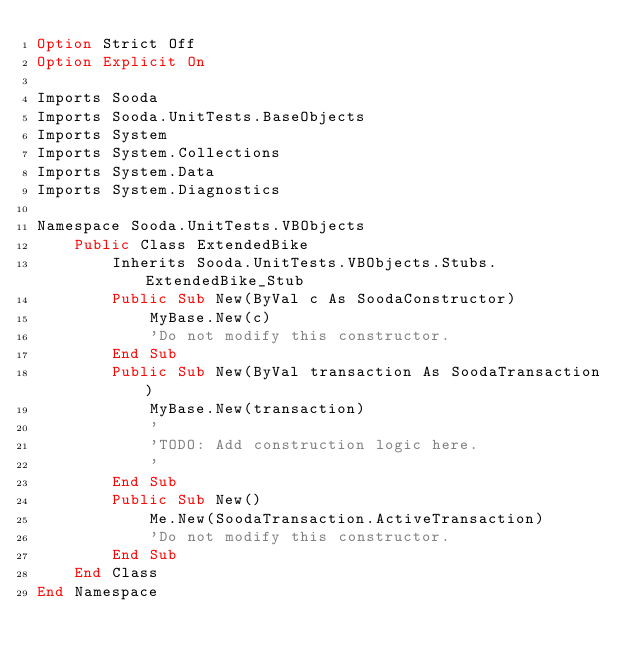<code> <loc_0><loc_0><loc_500><loc_500><_VisualBasic_>Option Strict Off
Option Explicit On

Imports Sooda
Imports Sooda.UnitTests.BaseObjects
Imports System
Imports System.Collections
Imports System.Data
Imports System.Diagnostics

Namespace Sooda.UnitTests.VBObjects
    Public Class ExtendedBike
        Inherits Sooda.UnitTests.VBObjects.Stubs.ExtendedBike_Stub
        Public Sub New(ByVal c As SoodaConstructor)
            MyBase.New(c)
            'Do not modify this constructor.
        End Sub
        Public Sub New(ByVal transaction As SoodaTransaction)
            MyBase.New(transaction)
            '
            'TODO: Add construction logic here.
            '
        End Sub
        Public Sub New()
            Me.New(SoodaTransaction.ActiveTransaction)
            'Do not modify this constructor.
        End Sub
    End Class
End Namespace
</code> 